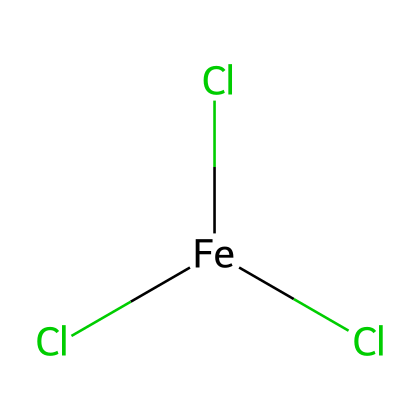What is the central metal atom in this compound? The SMILES representation indicates the presence of iron, which is the central atom bonded to three chlorine atoms. Iron is positioned at the start of the SMILES notation.
Answer: iron How many chlorine atoms are present in this molecule? The SMILES representation shows three chlorine atoms, indicated by the three occurrences of 'Cl' following the iron atom.
Answer: three What is the oxidation state of iron in ferric chloride? Ferric chloride contains iron in the +3 oxidation state, which is implied by the name "ferric." This is also evident from the combination with three chloride ions (each with -1 charge).
Answer: +3 What type of compound is ferric chloride? The structure of ferric chloride is composed of metal and nonmetal elements, fitting the definition of an ionic compound. Its formation involves the transfer of electrons from iron to chlorine.
Answer: ionic What is the coordinate bond type found in ferric chloride? Ferric chloride contains coordinate (dative covalent) bonds where chlorine atoms donate an electron pair to form bonds with iron. This is typical for a metal complex.
Answer: coordinate How would you classify the bonding in this molecule based on its elemental composition? The bonding in ferric chloride can be classified as ionic due to the high electronegativity difference between iron and chlorine, leading to electron transfer rather than sharing.
Answer: ionic 